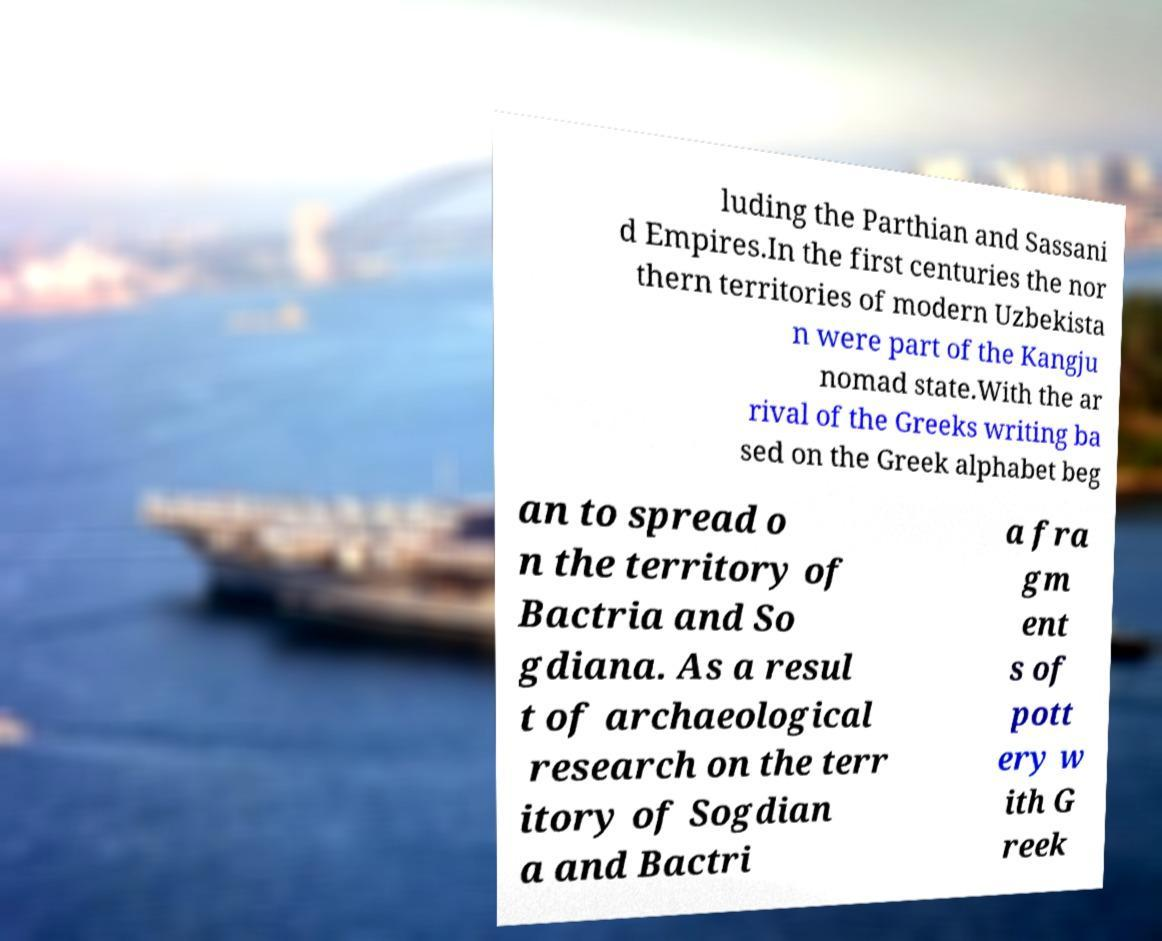What messages or text are displayed in this image? I need them in a readable, typed format. luding the Parthian and Sassani d Empires.In the first centuries the nor thern territories of modern Uzbekista n were part of the Kangju nomad state.With the ar rival of the Greeks writing ba sed on the Greek alphabet beg an to spread o n the territory of Bactria and So gdiana. As a resul t of archaeological research on the terr itory of Sogdian a and Bactri a fra gm ent s of pott ery w ith G reek 